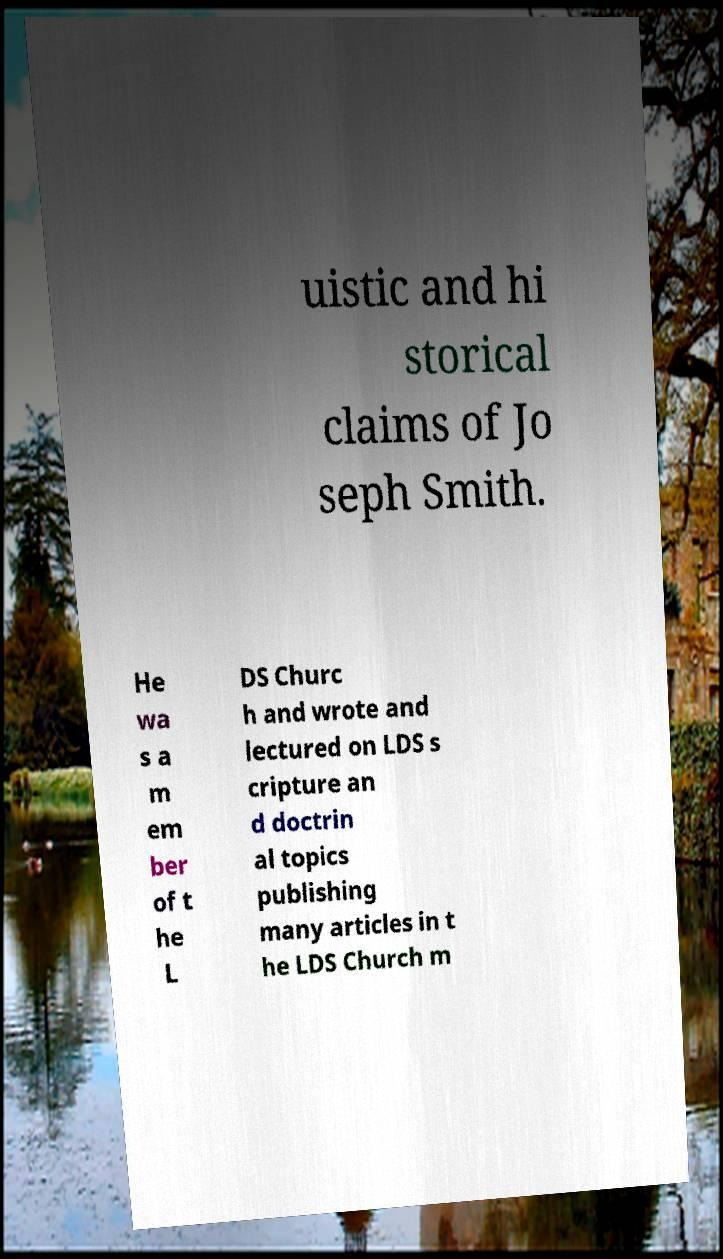I need the written content from this picture converted into text. Can you do that? uistic and hi storical claims of Jo seph Smith. He wa s a m em ber of t he L DS Churc h and wrote and lectured on LDS s cripture an d doctrin al topics publishing many articles in t he LDS Church m 